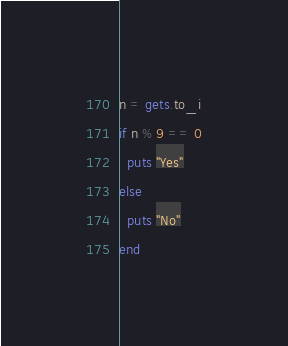<code> <loc_0><loc_0><loc_500><loc_500><_Ruby_>n = gets.to_i
if n % 9 == 0
  puts "Yes"
else
  puts "No"
end</code> 